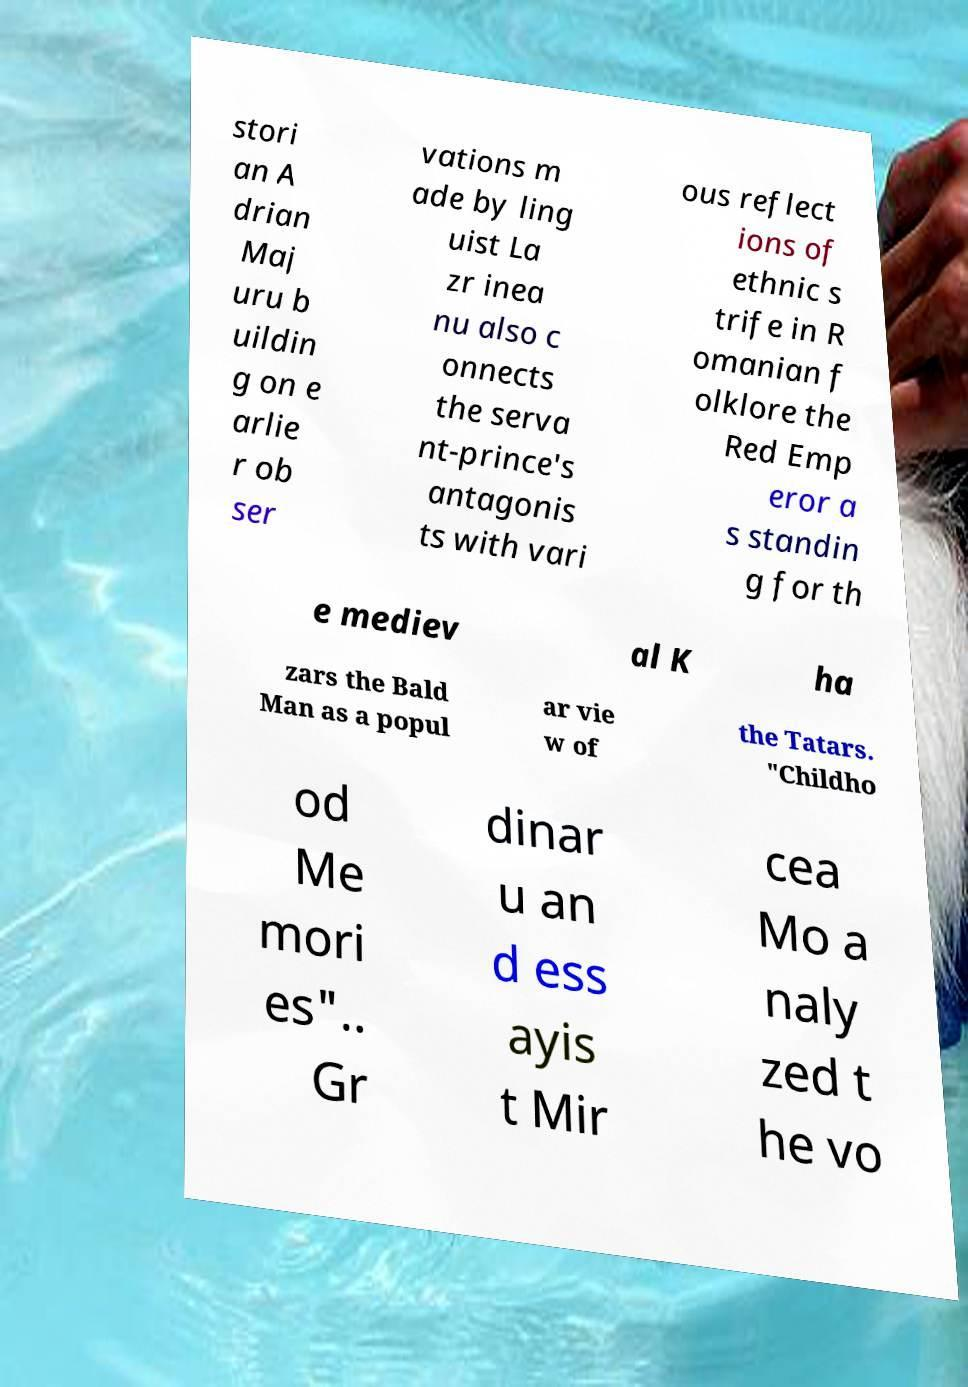For documentation purposes, I need the text within this image transcribed. Could you provide that? stori an A drian Maj uru b uildin g on e arlie r ob ser vations m ade by ling uist La zr inea nu also c onnects the serva nt-prince's antagonis ts with vari ous reflect ions of ethnic s trife in R omanian f olklore the Red Emp eror a s standin g for th e mediev al K ha zars the Bald Man as a popul ar vie w of the Tatars. "Childho od Me mori es".. Gr dinar u an d ess ayis t Mir cea Mo a naly zed t he vo 